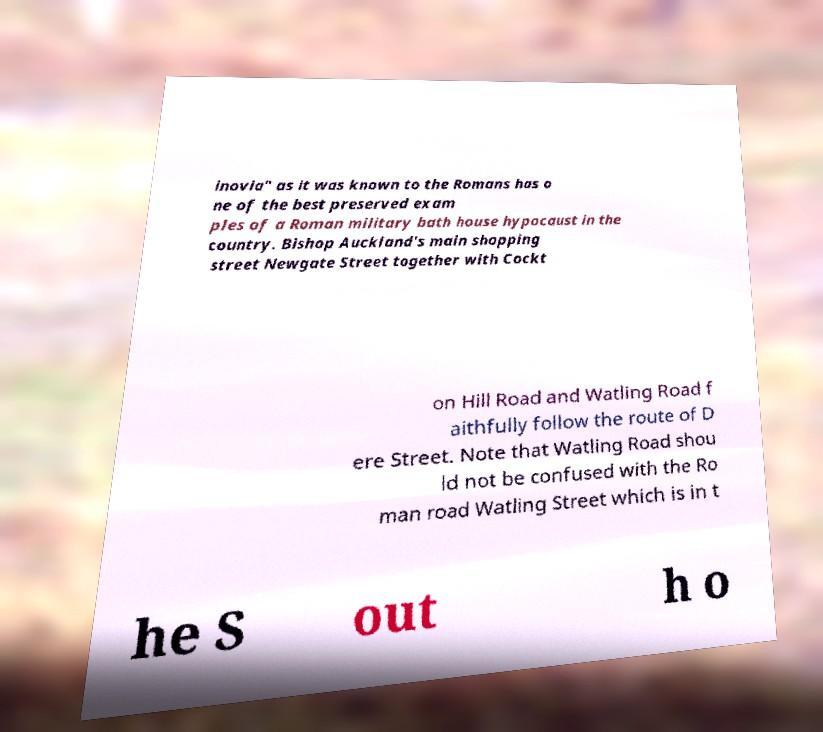Can you accurately transcribe the text from the provided image for me? inovia" as it was known to the Romans has o ne of the best preserved exam ples of a Roman military bath house hypocaust in the country. Bishop Auckland's main shopping street Newgate Street together with Cockt on Hill Road and Watling Road f aithfully follow the route of D ere Street. Note that Watling Road shou ld not be confused with the Ro man road Watling Street which is in t he S out h o 